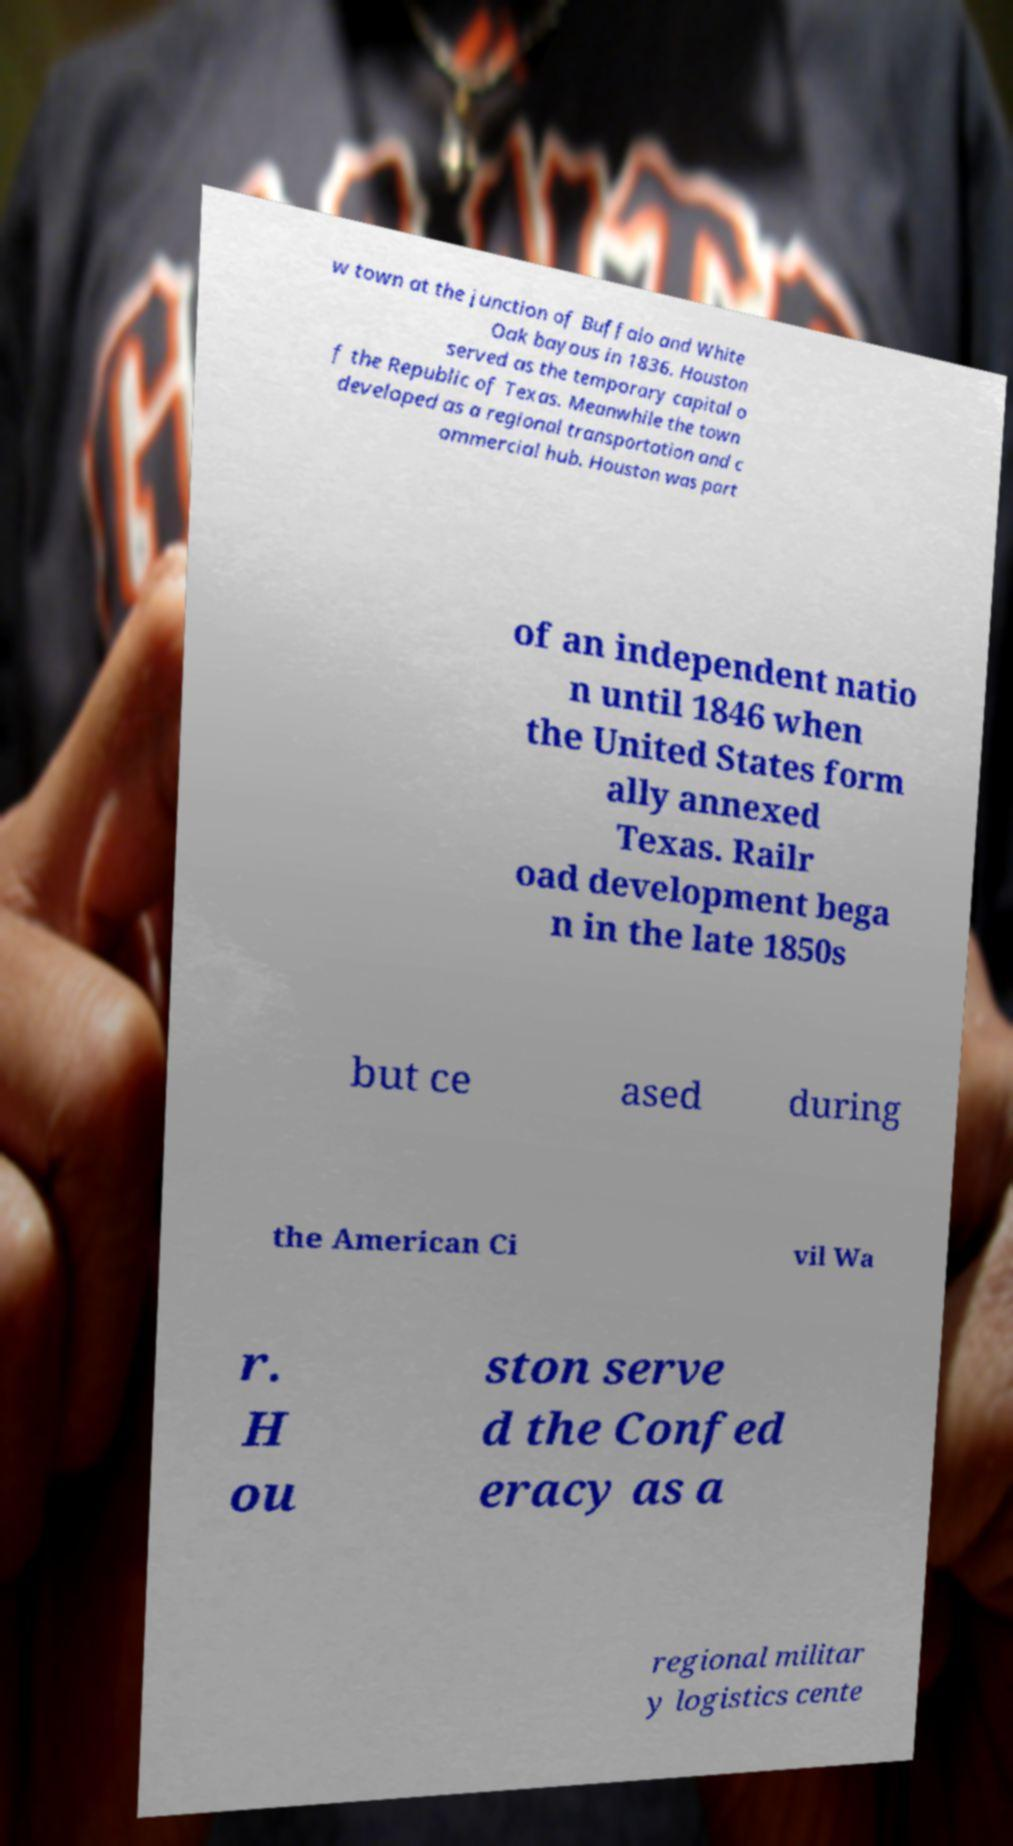What messages or text are displayed in this image? I need them in a readable, typed format. w town at the junction of Buffalo and White Oak bayous in 1836. Houston served as the temporary capital o f the Republic of Texas. Meanwhile the town developed as a regional transportation and c ommercial hub. Houston was part of an independent natio n until 1846 when the United States form ally annexed Texas. Railr oad development bega n in the late 1850s but ce ased during the American Ci vil Wa r. H ou ston serve d the Confed eracy as a regional militar y logistics cente 